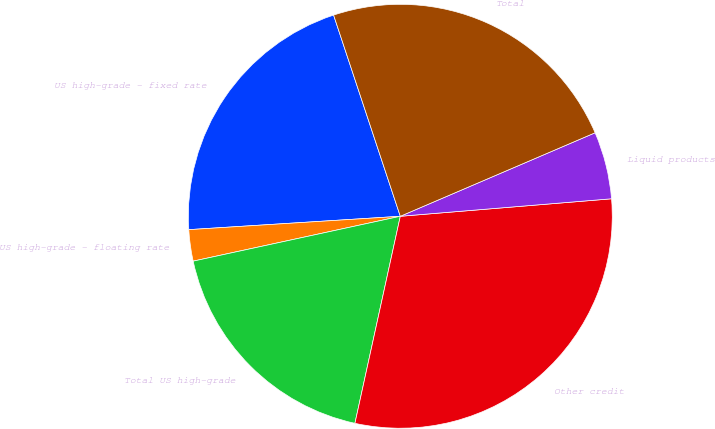Convert chart. <chart><loc_0><loc_0><loc_500><loc_500><pie_chart><fcel>US high-grade - fixed rate<fcel>US high-grade - floating rate<fcel>Total US high-grade<fcel>Other credit<fcel>Liquid products<fcel>Total<nl><fcel>20.91%<fcel>2.39%<fcel>18.17%<fcel>29.75%<fcel>5.13%<fcel>23.65%<nl></chart> 